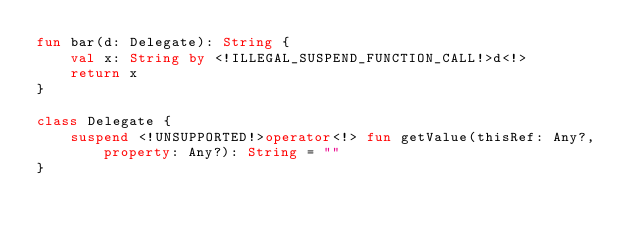Convert code to text. <code><loc_0><loc_0><loc_500><loc_500><_Kotlin_>fun bar(d: Delegate): String {
    val x: String by <!ILLEGAL_SUSPEND_FUNCTION_CALL!>d<!>
    return x
}

class Delegate {
    suspend <!UNSUPPORTED!>operator<!> fun getValue(thisRef: Any?, property: Any?): String = ""
}
</code> 